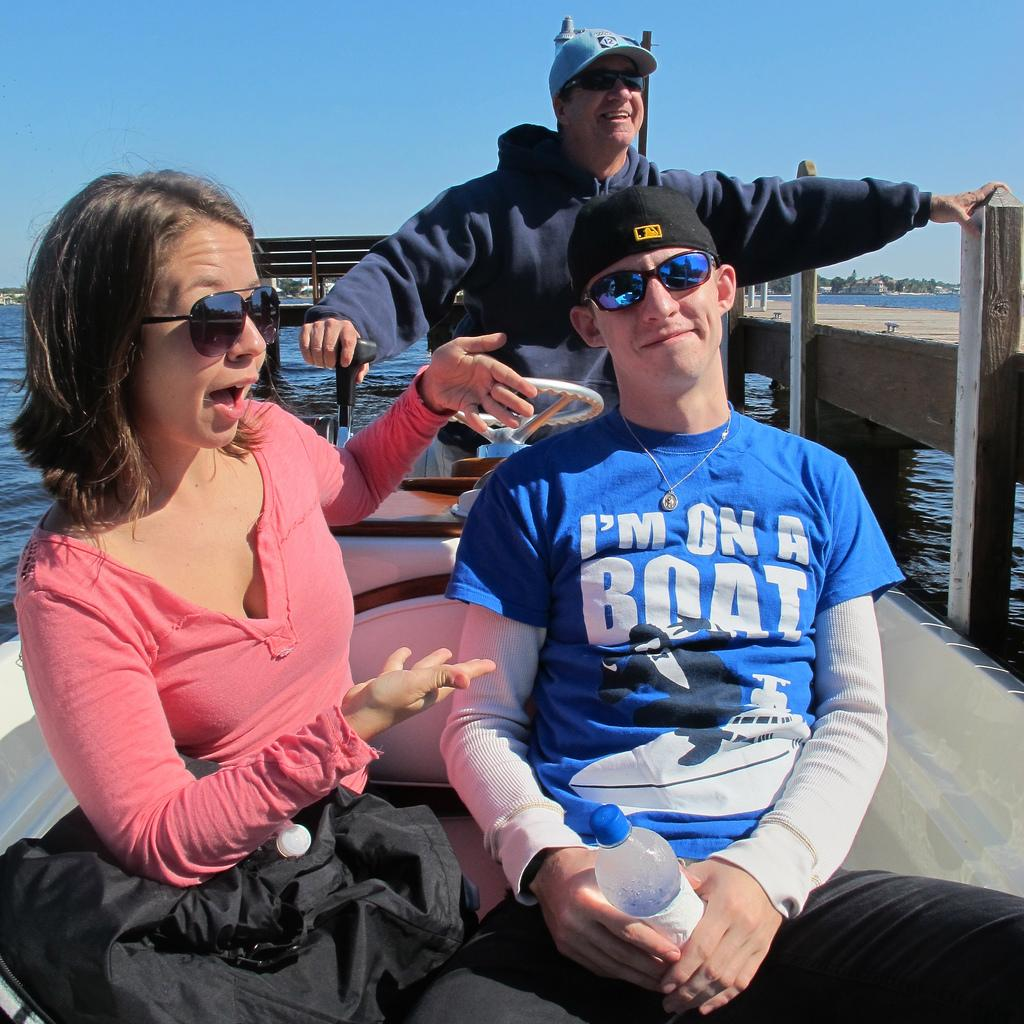<image>
Summarize the visual content of the image. Man wearing a "I'm on a boat" shirt sitting with a woman. 